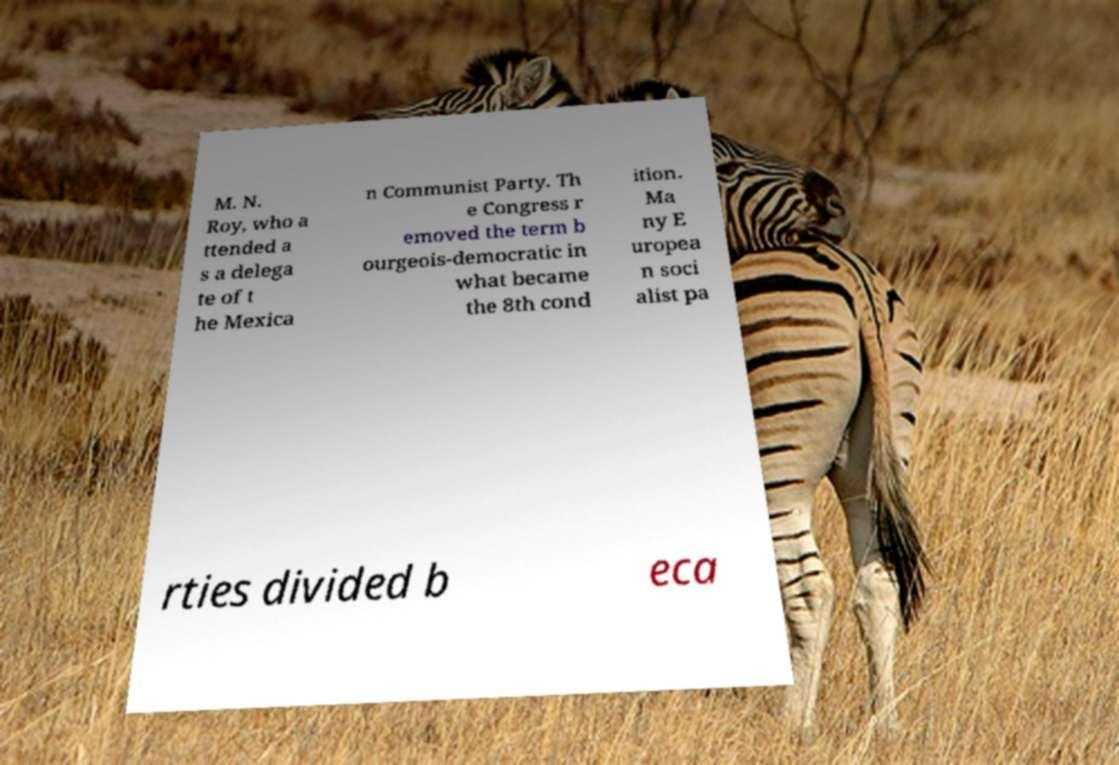Could you assist in decoding the text presented in this image and type it out clearly? M. N. Roy, who a ttended a s a delega te of t he Mexica n Communist Party. Th e Congress r emoved the term b ourgeois-democratic in what became the 8th cond ition. Ma ny E uropea n soci alist pa rties divided b eca 